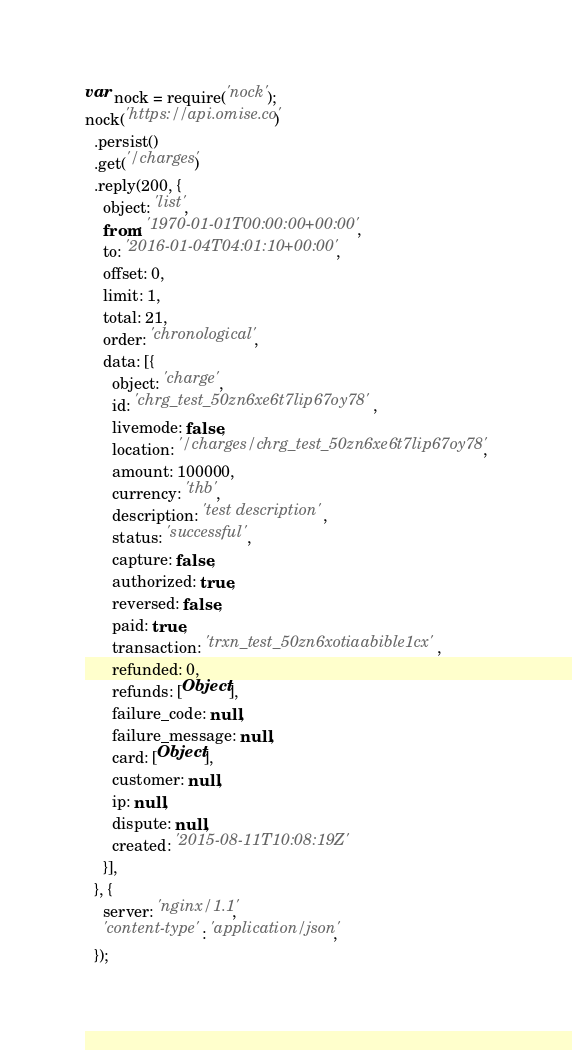<code> <loc_0><loc_0><loc_500><loc_500><_JavaScript_>var nock = require('nock');
nock('https://api.omise.co')
  .persist()
  .get('/charges')
  .reply(200, {
    object: 'list',
    from: '1970-01-01T00:00:00+00:00',
    to: '2016-01-04T04:01:10+00:00',
    offset: 0,
    limit: 1,
    total: 21,
    order: 'chronological',
    data: [{
      object: 'charge',
      id: 'chrg_test_50zn6xe6t7lip67oy78',
      livemode: false,
      location: '/charges/chrg_test_50zn6xe6t7lip67oy78',
      amount: 100000,
      currency: 'thb',
      description: 'test description',
      status: 'successful',
      capture: false,
      authorized: true,
      reversed: false,
      paid: true,
      transaction: 'trxn_test_50zn6xotiaabible1cx',
      refunded: 0,
      refunds: [Object],
      failure_code: null,
      failure_message: null,
      card: [Object],
      customer: null,
      ip: null,
      dispute: null,
      created: '2015-08-11T10:08:19Z'
    }],
  }, {
    server: 'nginx/1.1',
    'content-type': 'application/json',
  });
</code> 